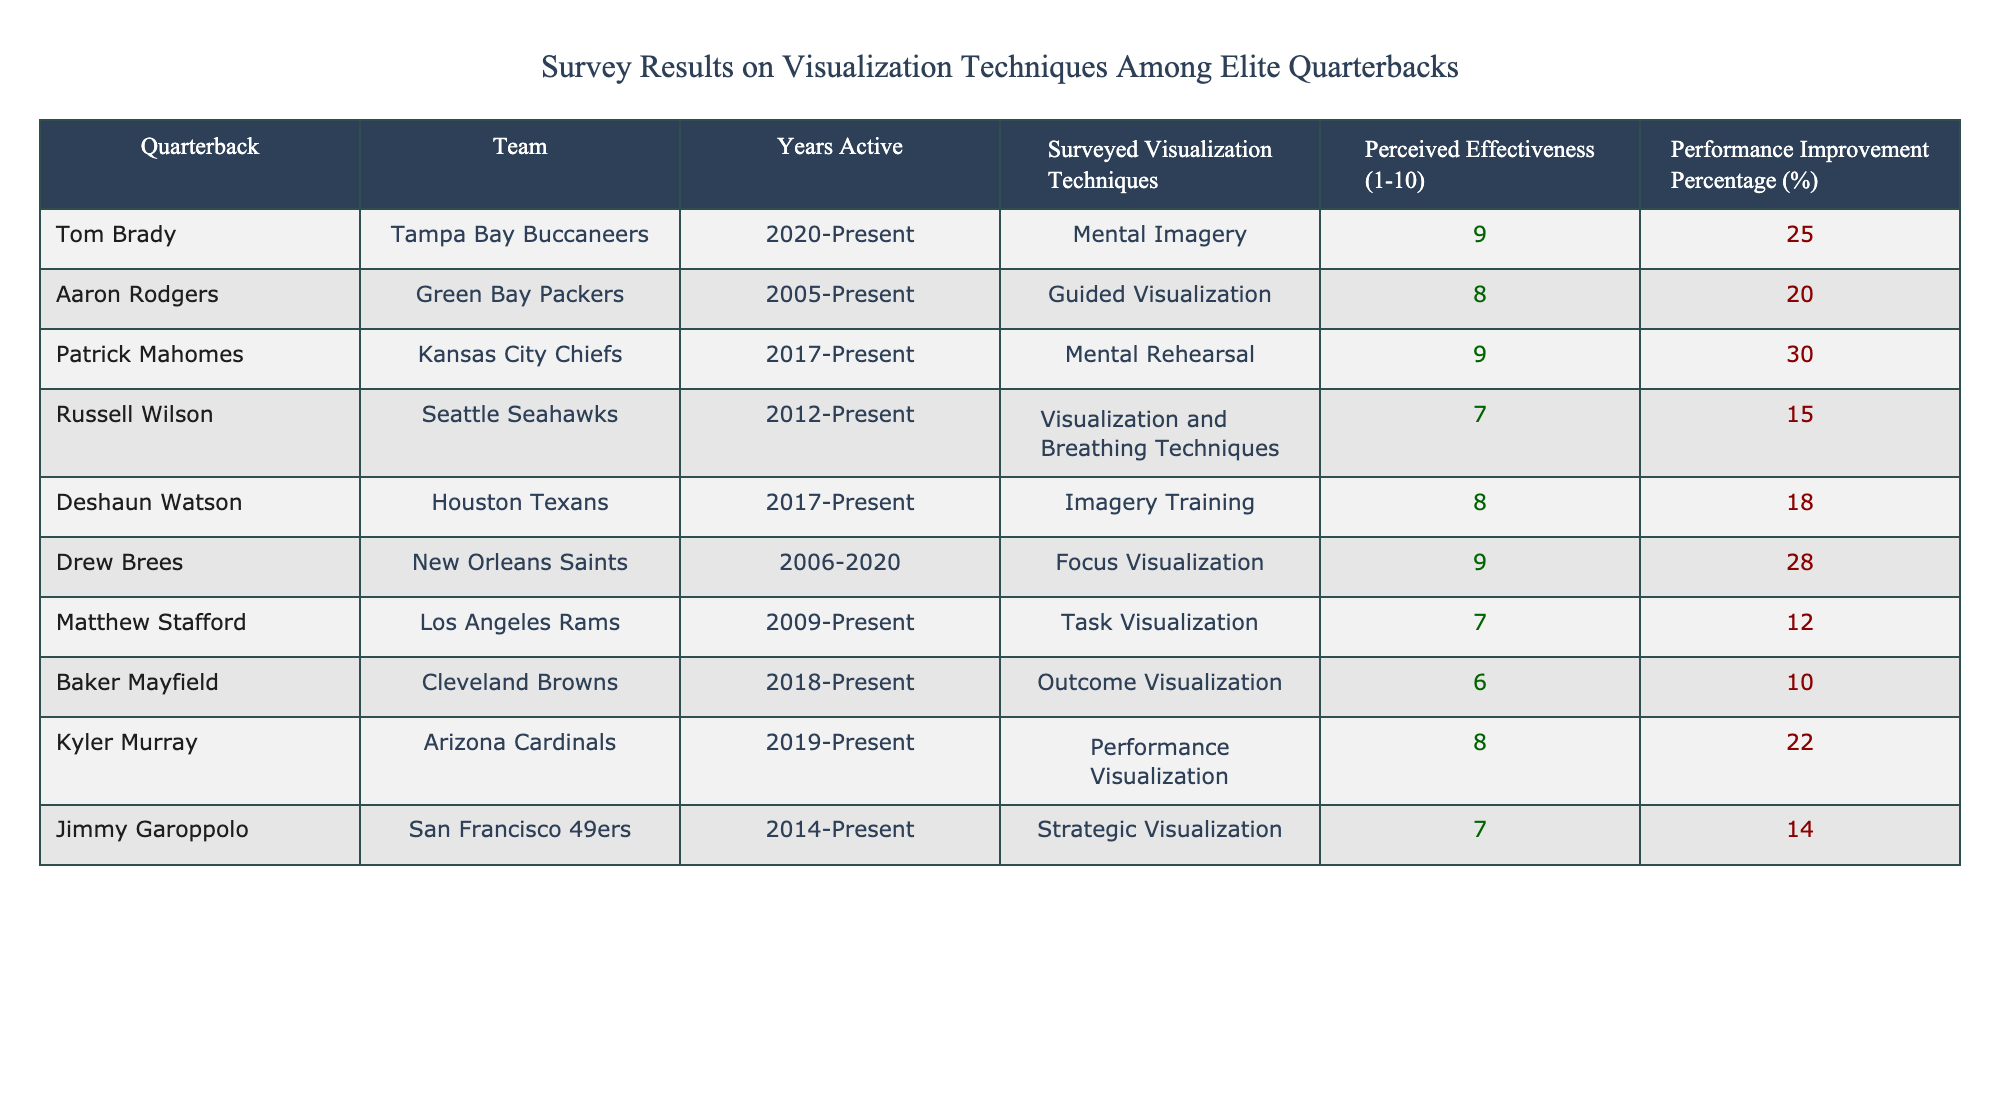What is the perceived effectiveness rating of Patrick Mahomes? The table shows the column for "Quarterback" and "Perceived Effectiveness (1-10)." By locating Patrick Mahomes in the "Quarterback" column, we see that his perceived effectiveness rating is 9.
Answer: 9 Which quarterback reported the highest performance improvement percentage? Looking at the "Performance Improvement Percentage (%)" column, we can identify the percentage for each quarterback. By comparing these values, we find that Patrick Mahomes has the highest at 30%.
Answer: 30% How many quarterbacks scored an effectiveness rating of 8 or higher? We need to filter the "Perceived Effectiveness (1-10)" column for values that are 8 or higher. The quarterbacks that meet this criterion are Tom Brady, Aaron Rodgers, Patrick Mahomes, Deshaun Watson, and Drew Brees, totaling 5 quarterbacks.
Answer: 5 Is there a quarterback who reported a performance improvement of 10% or less? By examining the "Performance Improvement Percentage (%)" column, we must check if any values are 10% or below. The only quarterbacks that satisfy this condition are Baker Mayfield and Matthew Stafford. Therefore, the answer is yes, there are two quarterbacks.
Answer: Yes What is the average performance improvement percentage of the quarterbacks who used Mental Imagery techniques? The only quarterback that reported using Mental Imagery is Tom Brady, who has a performance improvement percentage of 25%. Since there is only one data point, the average is also 25%.
Answer: 25 What is the range of perceived effectiveness ratings among the quarterbacks surveyed? To find the range, we need to identify the highest and lowest values in the "Perceived Effectiveness (1-10)" column. The highest is 9 (Brady, Mahomes, Brees), and the lowest is 6 (Mayfield). So the range can be calculated as 9 - 6 = 3.
Answer: 3 Did more quarterbacks report using visualization techniques related to mental imagery or guided techniques? We evaluate the "Surveyed Visualization Techniques" column for types related to mental imagery, which includes Mental Imagery, Mental Rehearsal, and Imagery Training (3 quarterbacks), versus guided techniques, which includes Guided Visualization and Focus Visualization (2 quarterbacks). There are more using mental imagery techniques.
Answer: Yes Which quarterback has the lowest perceived effectiveness score, and what is it? Looking in the "Perceived Effectiveness (1-10)" column, we find Baker Mayfield with a score of 6. Thus, he has the lowest effectiveness rating among those surveyed.
Answer: 6 How many years of active play do the quarterbacks with the highest perceived effectiveness ratings (9) have? The quarterbacks who have a perceived effectiveness rating of 9 are Tom Brady, Patrick Mahomes, and Drew Brees. Counting the years active: Brady (3 years), Mahomes (6 years), and Brees (15 years). The total number of years is 3 + 6 + 15 = 24 years.
Answer: 24 